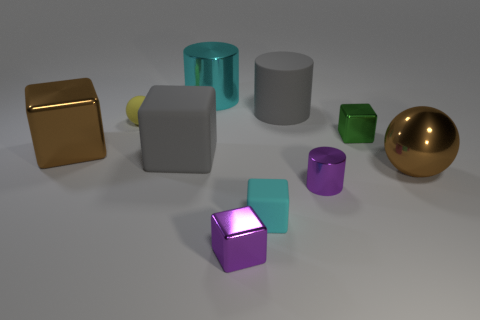What number of other objects are the same material as the yellow thing?
Ensure brevity in your answer.  3. Are there more small purple metal objects than things?
Offer a very short reply. No. What is the material of the large cube that is in front of the big cube that is left of the tiny yellow matte object that is to the left of the small green shiny cube?
Give a very brief answer. Rubber. Is the color of the big metal ball the same as the big shiny cube?
Your answer should be compact. Yes. Are there any large shiny cubes of the same color as the large sphere?
Your response must be concise. Yes. There is a gray thing that is the same size as the gray rubber cylinder; what shape is it?
Keep it short and to the point. Cube. Is the number of cyan objects less than the number of cylinders?
Your answer should be compact. Yes. What number of green objects have the same size as the purple shiny cylinder?
Ensure brevity in your answer.  1. What is the shape of the object that is the same color as the big metallic ball?
Provide a short and direct response. Cube. What is the material of the small yellow sphere?
Offer a very short reply. Rubber. 